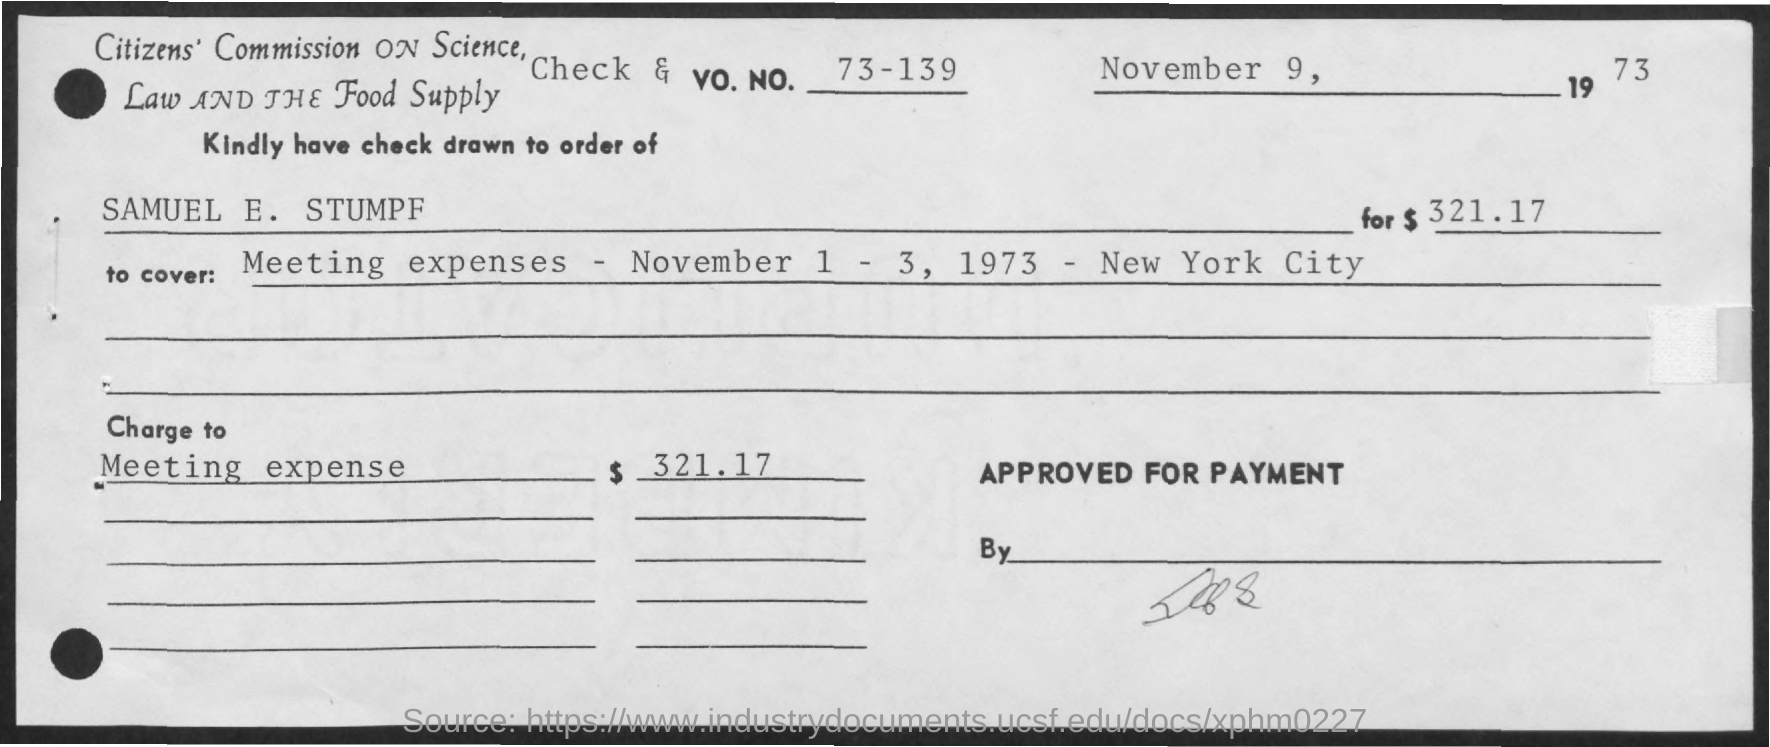What is the Vo. No. mentioned in the check?
Give a very brief answer. 73 - 139. What is the date of the check?
Your answer should be very brief. November 9, 1973. What is the amount of check issued?
Your answer should be compact. $321.17. In whose name, the check is issued?
Keep it short and to the point. SAMUEL E. STUMPF. What charges are covered in the check?
Give a very brief answer. Meeting expenses - November 1 - 3, 1973 - New York City. 